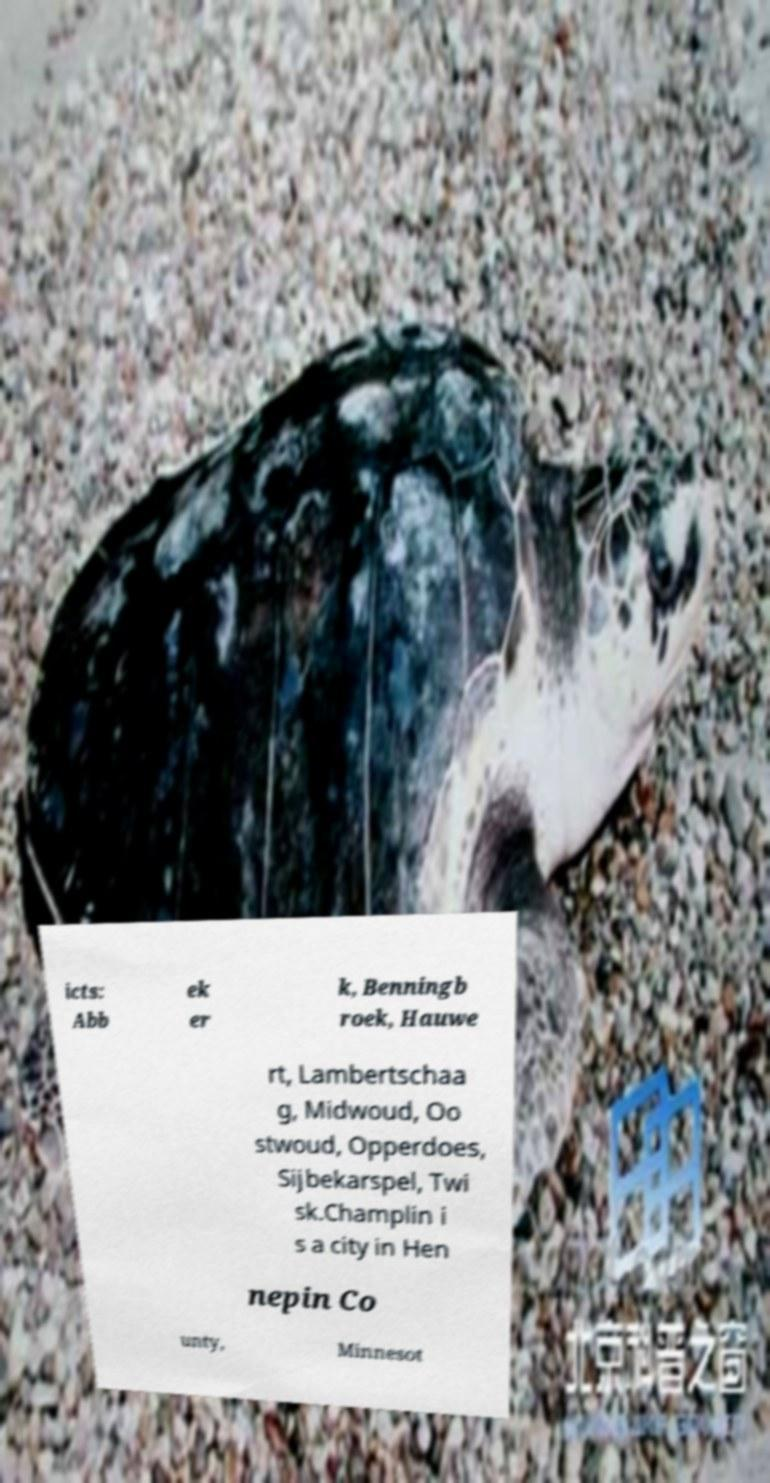I need the written content from this picture converted into text. Can you do that? icts: Abb ek er k, Benningb roek, Hauwe rt, Lambertschaa g, Midwoud, Oo stwoud, Opperdoes, Sijbekarspel, Twi sk.Champlin i s a city in Hen nepin Co unty, Minnesot 